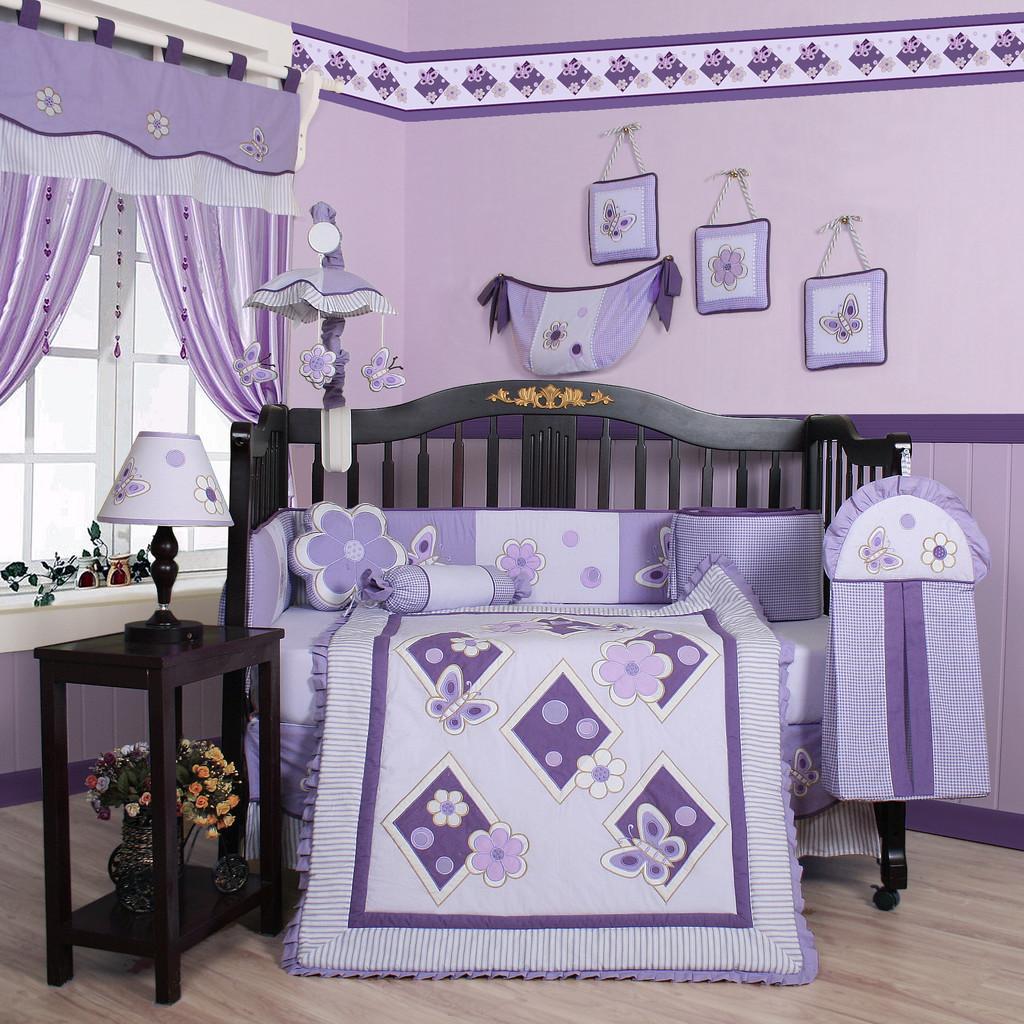Could you give a brief overview of what you see in this image? In the picture I can see a sofa which has pillows and some other objects on it. In the background I can see a wall which has some objects attached to it. On the left side I can see a window, curtains, a light lamp on a table and some other objects. This is an inside view of a room. 